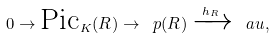<formula> <loc_0><loc_0><loc_500><loc_500>0 \to \text {Pic} _ { K } ( R ) \to \ p ( R ) \xrightarrow { h _ { R } } \ a u ,</formula> 